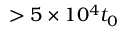Convert formula to latex. <formula><loc_0><loc_0><loc_500><loc_500>> 5 \times 1 0 ^ { 4 } t _ { 0 }</formula> 